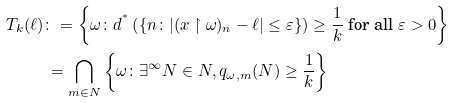Convert formula to latex. <formula><loc_0><loc_0><loc_500><loc_500>T _ { k } ( \ell ) & \colon = \left \{ \omega \colon d ^ { ^ { * } } \left ( \{ n \colon | ( x \upharpoonright \omega ) _ { n } - \ell | \leq \varepsilon \} \right ) \geq \frac { 1 } { k } \text { for all } \varepsilon > 0 \right \} \\ & \, = \bigcap _ { m \in N } \left \{ \omega \colon \exists ^ { \infty } N \in N , q _ { \omega , m } ( N ) \geq \frac { 1 } { k } \right \}</formula> 